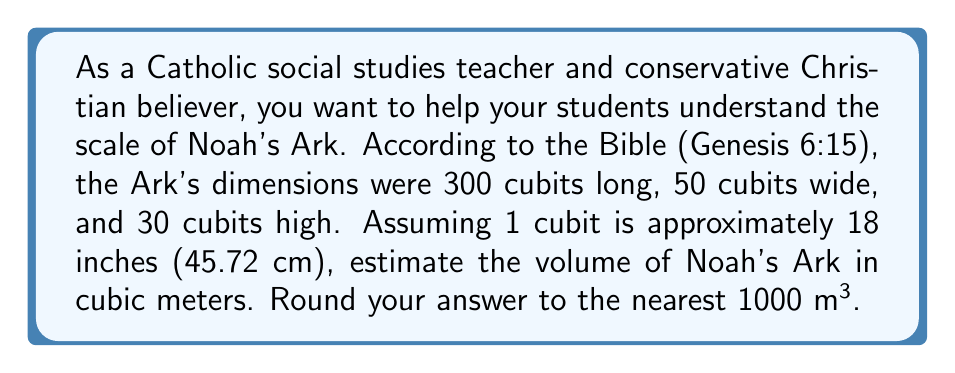Can you answer this question? To estimate the volume of Noah's Ark, we'll use the formula for the volume of a rectangular prism:

$$V = l \times w \times h$$

Where $V$ is volume, $l$ is length, $w$ is width, and $h$ is height.

First, let's convert the dimensions from cubits to meters:

1. Length: $300 \text{ cubits} \times 0.4572 \text{ m/cubit} = 137.16 \text{ m}$
2. Width: $50 \text{ cubits} \times 0.4572 \text{ m/cubit} = 22.86 \text{ m}$
3. Height: $30 \text{ cubits} \times 0.4572 \text{ m/cubit} = 13.716 \text{ m}$

Now, let's calculate the volume:

$$V = 137.16 \text{ m} \times 22.86 \text{ m} \times 13.716 \text{ m} = 43,006.72 \text{ m}^3$$

Rounding to the nearest 1000 m³, we get 43,000 m³.
Answer: 43,000 m³ 